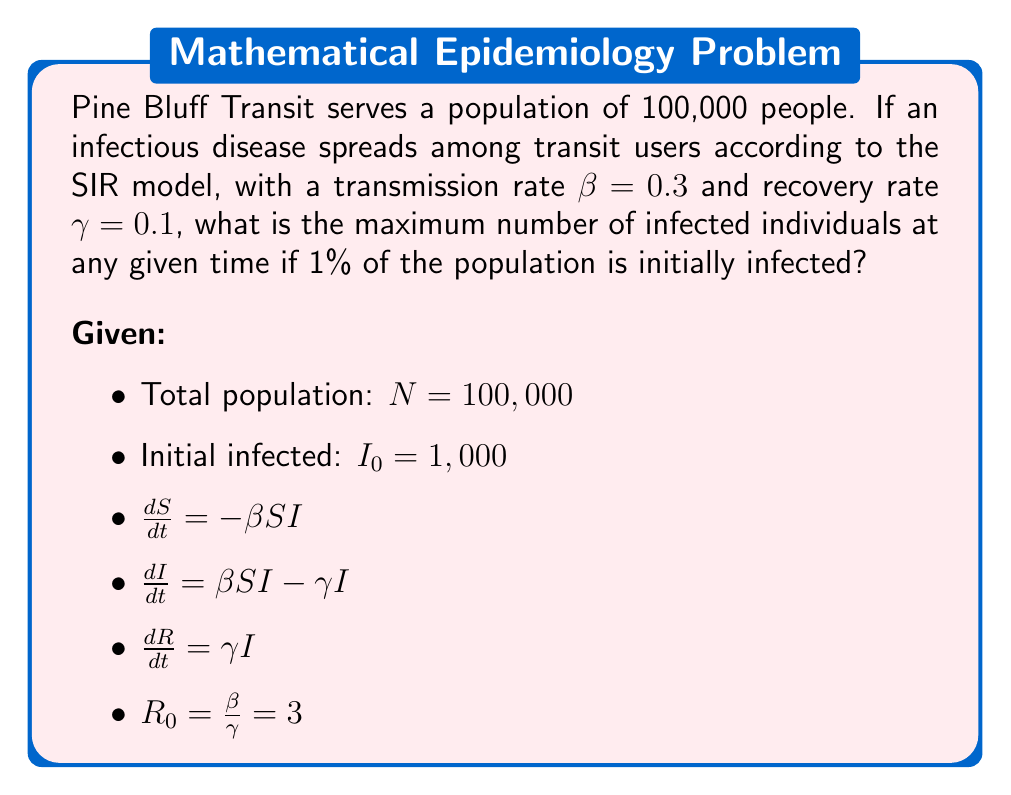Can you answer this question? To find the maximum number of infected individuals, we need to determine when $\frac{dI}{dt} = 0$. This occurs when:

1) $\beta SI - \gamma I = 0$
2) $S = \frac{\gamma}{\beta} = \frac{1}{R_0} = \frac{1}{3}$

The fraction of susceptible population at the peak of infection is $\frac{1}{R_0}$. We can use this to find the maximum number of infected:

3) $S + I + R = 1$ (total population fraction)
4) $\frac{1}{3} + I_{max} + R = 1$
5) $I_{max} = 1 - \frac{1}{3} - R$

To find $R$, we use the conservation of population and the fact that initially, $R_0 = 0$:

6) $S_0 + I_0 + R_0 = 1$
7) $S_0 = 1 - I_0 = 1 - 0.01 = 0.99$

Now we can use the relation $S = S_0 e^{-R_0 R}$:

8) $\frac{1}{3} = 0.99 e^{-3R}$
9) $R = \frac{1}{3} \ln(2.97) \approx 0.3634$

Substituting this back into equation 5:

10) $I_{max} = 1 - \frac{1}{3} - 0.3634 = 0.3033$

Finally, multiply by the total population:

11) $I_{max} * N = 0.3033 * 100,000 = 30,330$
Answer: 30,330 individuals 